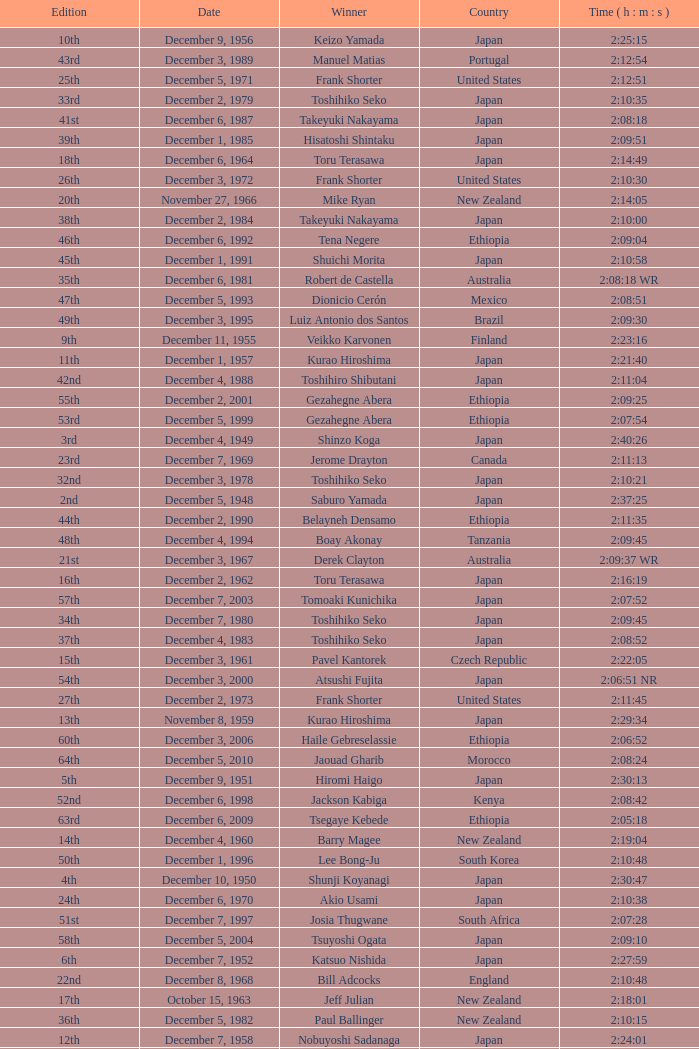What was the nationality of the winner of the 42nd Edition? Japan. 